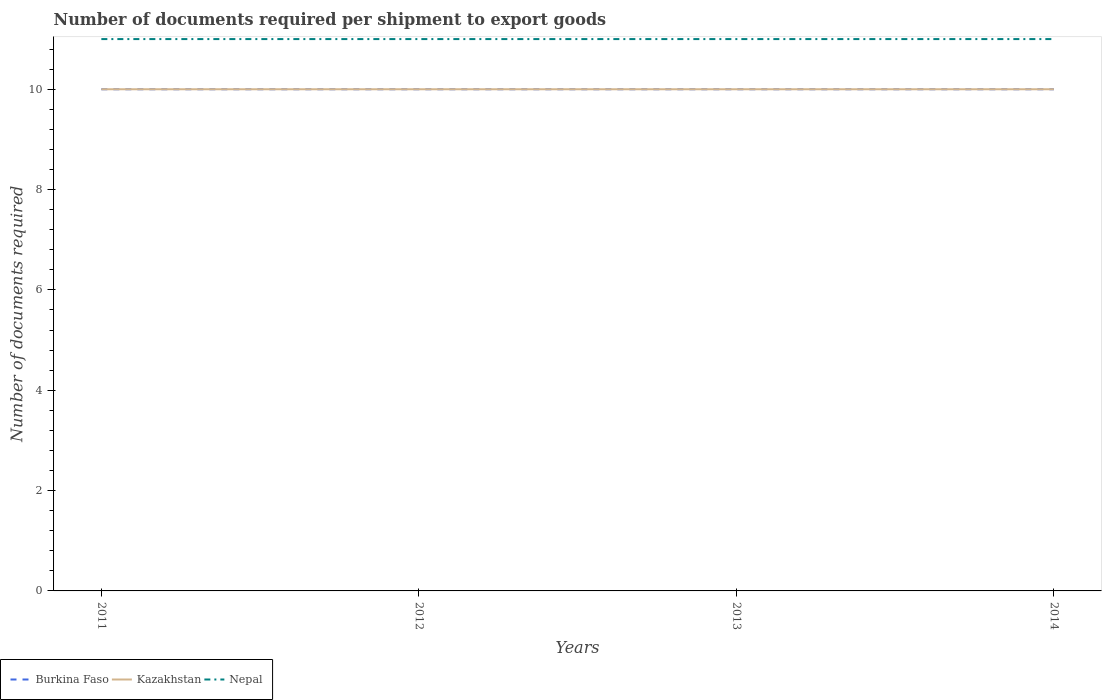How many different coloured lines are there?
Offer a terse response. 3. Does the line corresponding to Kazakhstan intersect with the line corresponding to Nepal?
Your answer should be compact. No. Across all years, what is the maximum number of documents required per shipment to export goods in Kazakhstan?
Offer a terse response. 10. What is the difference between the highest and the second highest number of documents required per shipment to export goods in Kazakhstan?
Make the answer very short. 0. How many lines are there?
Keep it short and to the point. 3. How many years are there in the graph?
Offer a very short reply. 4. Are the values on the major ticks of Y-axis written in scientific E-notation?
Keep it short and to the point. No. What is the title of the graph?
Keep it short and to the point. Number of documents required per shipment to export goods. Does "Dominican Republic" appear as one of the legend labels in the graph?
Your response must be concise. No. What is the label or title of the Y-axis?
Ensure brevity in your answer.  Number of documents required. What is the Number of documents required of Kazakhstan in 2011?
Give a very brief answer. 10. What is the Number of documents required of Kazakhstan in 2012?
Your response must be concise. 10. What is the Number of documents required of Nepal in 2012?
Ensure brevity in your answer.  11. What is the Number of documents required in Burkina Faso in 2013?
Offer a terse response. 10. What is the Number of documents required of Kazakhstan in 2013?
Your answer should be very brief. 10. Across all years, what is the maximum Number of documents required in Burkina Faso?
Make the answer very short. 10. Across all years, what is the maximum Number of documents required in Kazakhstan?
Provide a short and direct response. 10. Across all years, what is the minimum Number of documents required of Burkina Faso?
Give a very brief answer. 10. Across all years, what is the minimum Number of documents required in Nepal?
Give a very brief answer. 11. What is the total Number of documents required in Kazakhstan in the graph?
Your response must be concise. 40. What is the difference between the Number of documents required in Kazakhstan in 2011 and that in 2012?
Give a very brief answer. 0. What is the difference between the Number of documents required in Nepal in 2011 and that in 2012?
Make the answer very short. 0. What is the difference between the Number of documents required in Kazakhstan in 2011 and that in 2013?
Your answer should be very brief. 0. What is the difference between the Number of documents required of Kazakhstan in 2011 and that in 2014?
Give a very brief answer. 0. What is the difference between the Number of documents required in Nepal in 2012 and that in 2013?
Your answer should be very brief. 0. What is the difference between the Number of documents required in Kazakhstan in 2012 and that in 2014?
Make the answer very short. 0. What is the difference between the Number of documents required of Nepal in 2013 and that in 2014?
Your response must be concise. 0. What is the difference between the Number of documents required of Burkina Faso in 2011 and the Number of documents required of Nepal in 2012?
Your response must be concise. -1. What is the difference between the Number of documents required in Burkina Faso in 2011 and the Number of documents required in Kazakhstan in 2013?
Your response must be concise. 0. What is the difference between the Number of documents required of Burkina Faso in 2011 and the Number of documents required of Nepal in 2014?
Provide a succinct answer. -1. What is the difference between the Number of documents required in Kazakhstan in 2011 and the Number of documents required in Nepal in 2014?
Offer a very short reply. -1. What is the difference between the Number of documents required of Kazakhstan in 2012 and the Number of documents required of Nepal in 2013?
Your answer should be very brief. -1. What is the difference between the Number of documents required of Burkina Faso in 2012 and the Number of documents required of Nepal in 2014?
Keep it short and to the point. -1. What is the difference between the Number of documents required in Kazakhstan in 2012 and the Number of documents required in Nepal in 2014?
Provide a short and direct response. -1. What is the difference between the Number of documents required in Burkina Faso in 2013 and the Number of documents required in Kazakhstan in 2014?
Your response must be concise. 0. What is the average Number of documents required of Burkina Faso per year?
Give a very brief answer. 10. What is the average Number of documents required of Kazakhstan per year?
Make the answer very short. 10. What is the average Number of documents required in Nepal per year?
Offer a terse response. 11. In the year 2011, what is the difference between the Number of documents required of Burkina Faso and Number of documents required of Kazakhstan?
Provide a short and direct response. 0. In the year 2011, what is the difference between the Number of documents required in Kazakhstan and Number of documents required in Nepal?
Keep it short and to the point. -1. In the year 2012, what is the difference between the Number of documents required in Burkina Faso and Number of documents required in Kazakhstan?
Make the answer very short. 0. In the year 2013, what is the difference between the Number of documents required in Burkina Faso and Number of documents required in Nepal?
Provide a succinct answer. -1. In the year 2013, what is the difference between the Number of documents required in Kazakhstan and Number of documents required in Nepal?
Offer a very short reply. -1. In the year 2014, what is the difference between the Number of documents required in Kazakhstan and Number of documents required in Nepal?
Ensure brevity in your answer.  -1. What is the ratio of the Number of documents required in Nepal in 2011 to that in 2012?
Provide a succinct answer. 1. What is the ratio of the Number of documents required of Burkina Faso in 2011 to that in 2013?
Offer a very short reply. 1. What is the ratio of the Number of documents required of Kazakhstan in 2011 to that in 2014?
Your answer should be compact. 1. What is the ratio of the Number of documents required in Burkina Faso in 2012 to that in 2013?
Give a very brief answer. 1. What is the ratio of the Number of documents required of Kazakhstan in 2012 to that in 2013?
Provide a succinct answer. 1. What is the ratio of the Number of documents required in Kazakhstan in 2012 to that in 2014?
Offer a very short reply. 1. What is the ratio of the Number of documents required in Nepal in 2012 to that in 2014?
Give a very brief answer. 1. What is the ratio of the Number of documents required in Burkina Faso in 2013 to that in 2014?
Give a very brief answer. 1. What is the ratio of the Number of documents required in Kazakhstan in 2013 to that in 2014?
Provide a succinct answer. 1. What is the difference between the highest and the second highest Number of documents required of Burkina Faso?
Give a very brief answer. 0. What is the difference between the highest and the second highest Number of documents required of Kazakhstan?
Provide a succinct answer. 0. What is the difference between the highest and the lowest Number of documents required of Burkina Faso?
Offer a terse response. 0. 